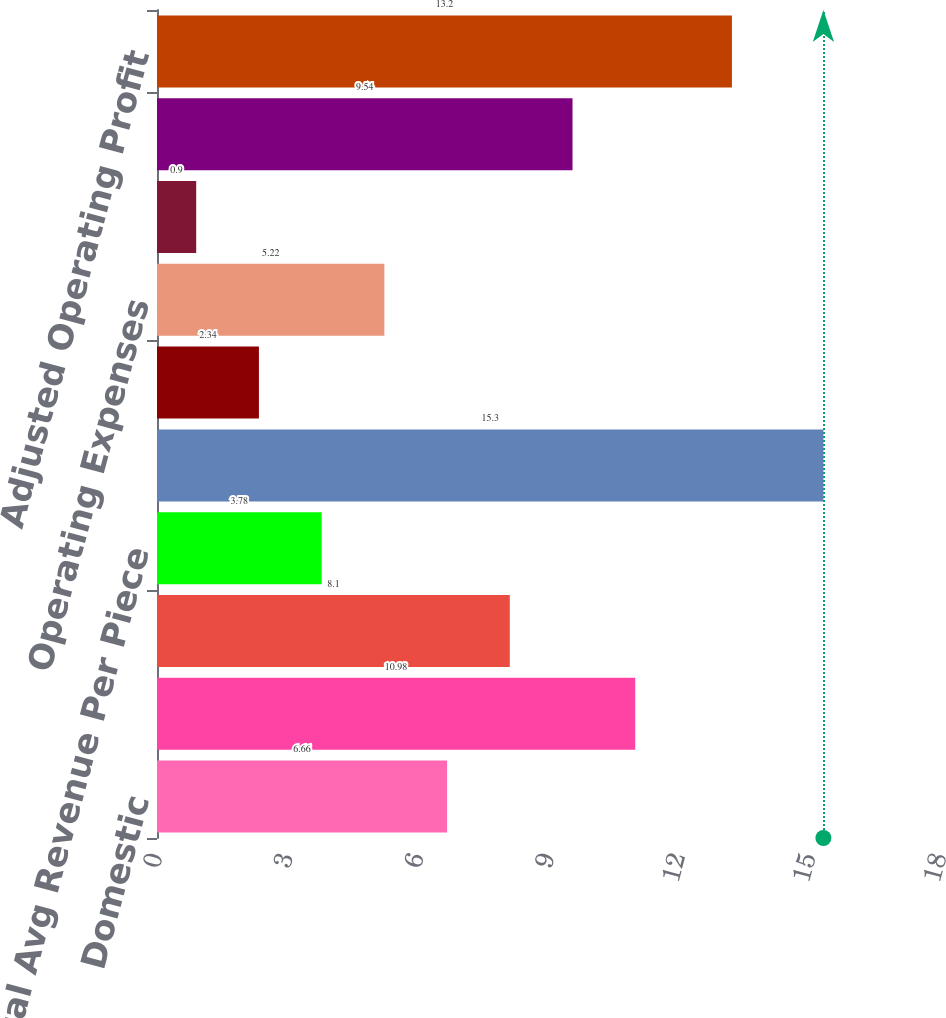Convert chart to OTSL. <chart><loc_0><loc_0><loc_500><loc_500><bar_chart><fcel>Domestic<fcel>Export<fcel>Total Avg Daily Package Volume<fcel>Total Avg Revenue Per Piece<fcel>Cargo & Other<fcel>Total Revenue<fcel>Operating Expenses<fcel>Adjusted Operating Expenses<fcel>Operating Profit<fcel>Adjusted Operating Profit<nl><fcel>6.66<fcel>10.98<fcel>8.1<fcel>3.78<fcel>15.3<fcel>2.34<fcel>5.22<fcel>0.9<fcel>9.54<fcel>13.2<nl></chart> 